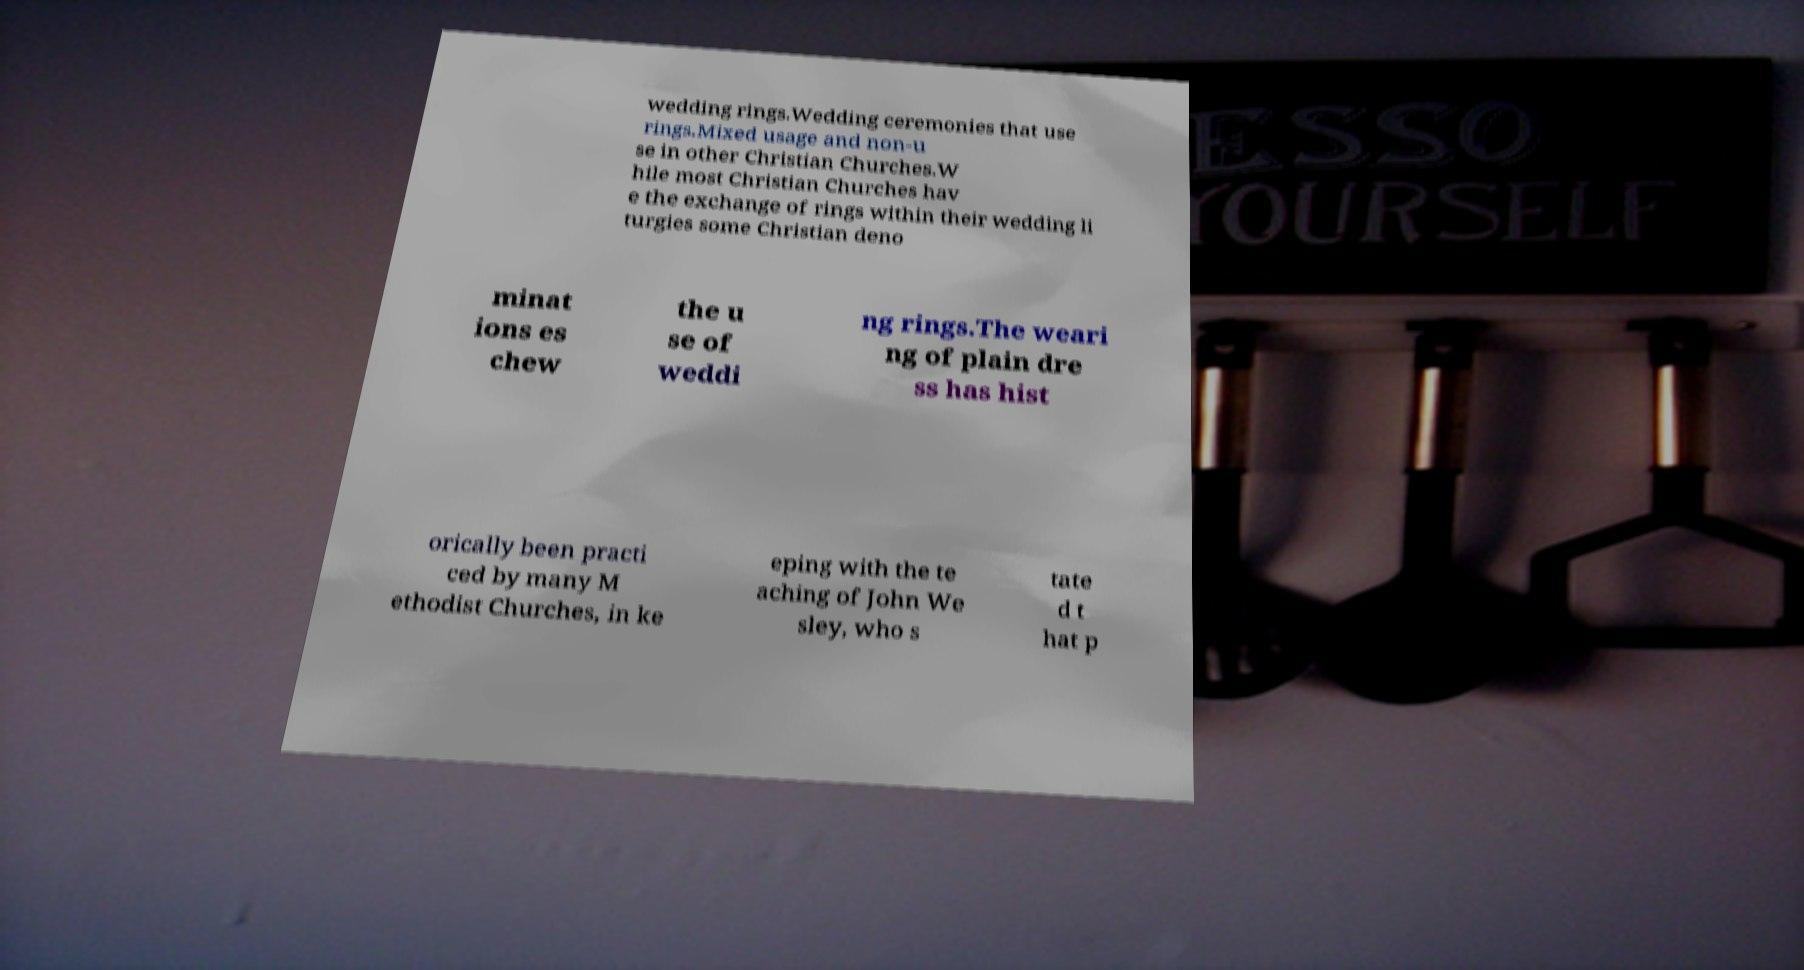Please read and relay the text visible in this image. What does it say? wedding rings.Wedding ceremonies that use rings.Mixed usage and non-u se in other Christian Churches.W hile most Christian Churches hav e the exchange of rings within their wedding li turgies some Christian deno minat ions es chew the u se of weddi ng rings.The weari ng of plain dre ss has hist orically been practi ced by many M ethodist Churches, in ke eping with the te aching of John We sley, who s tate d t hat p 